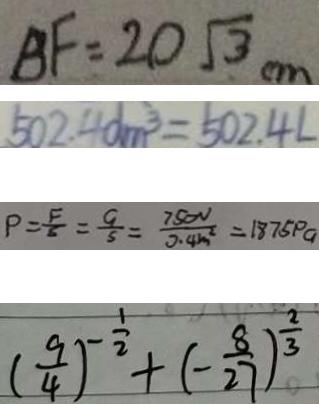<formula> <loc_0><loc_0><loc_500><loc_500>B F = 2 0 \sqrt { 3 } c m 
 5 0 2 . 4 d m ^ { 3 } = 5 0 2 . 4 L 
 P = \frac { F } { S } = \frac { 9 } { 5 } = \frac { 7 5 0 V } { 0 . 4 m ^ { 2 } } = 1 8 7 5 p a 
 ( \frac { 9 } { 4 } ) ^ { - \frac { 1 } { 2 } } + ( - \frac { 8 } { 2 7 } ) ^ { \frac { 2 } { 3 } }</formula> 